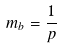<formula> <loc_0><loc_0><loc_500><loc_500>m _ { b } = \frac { 1 } { p }</formula> 